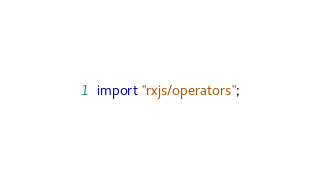Convert code to text. <code><loc_0><loc_0><loc_500><loc_500><_JavaScript_>import "rxjs/operators";
</code> 